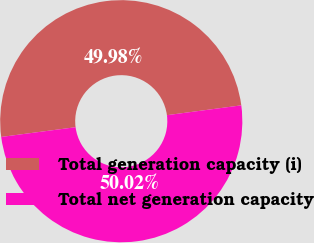Convert chart to OTSL. <chart><loc_0><loc_0><loc_500><loc_500><pie_chart><fcel>Total generation capacity (i)<fcel>Total net generation capacity<nl><fcel>49.98%<fcel>50.02%<nl></chart> 